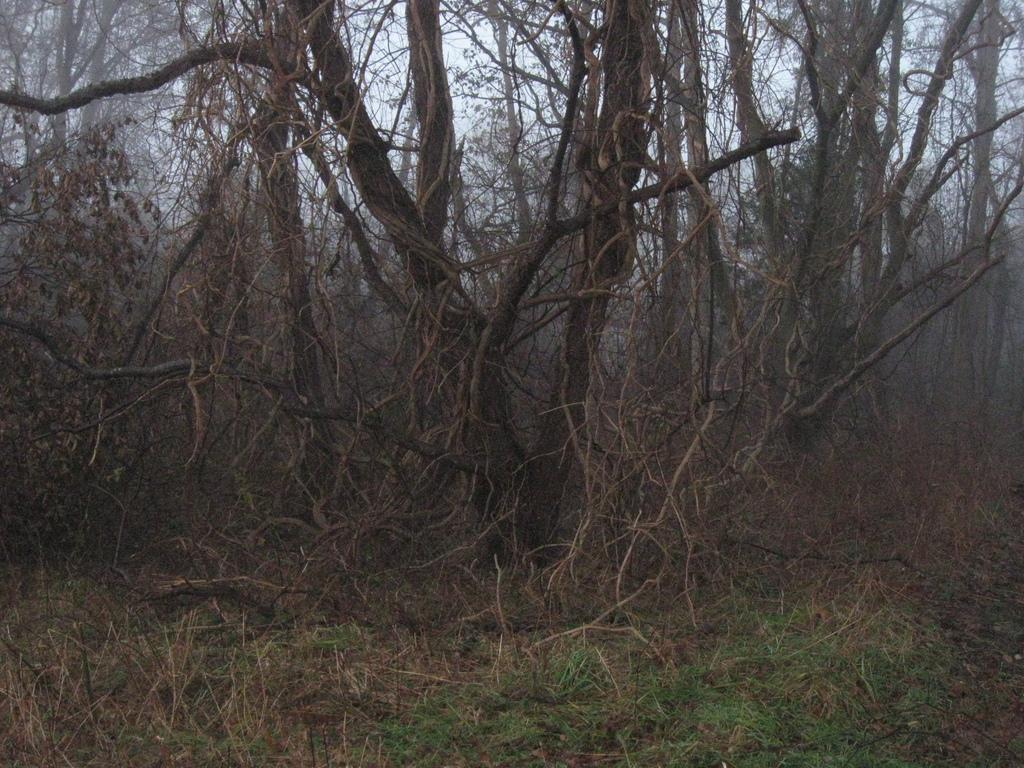What type of surface is on the floor in the image? There is grass on the floor in the image. What other types of vegetation can be seen in the image? There are plants and trees in the image. How do the trees in the image appear? The trees appear to be dried in the image. What is visible in the sky in the image? The sky is clear in the image. What degree of temperature is being experienced by the visitor in the image? There is no visitor present in the image, so it is not possible to determine the temperature they might be experiencing. 